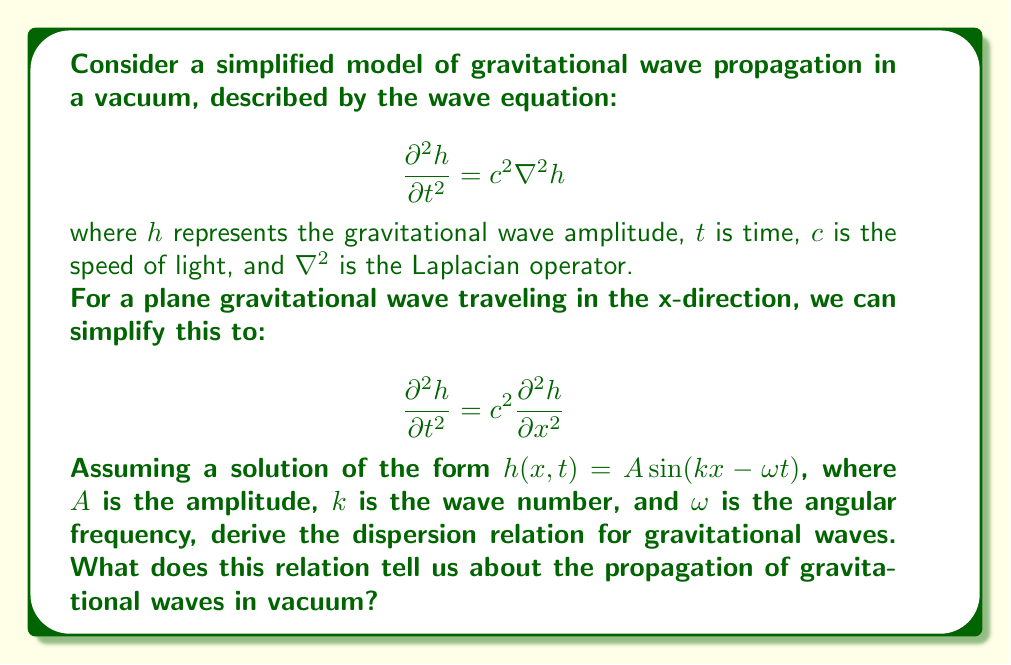Could you help me with this problem? Let's approach this step-by-step:

1) We start with the assumed solution: $h(x,t) = A \sin(kx - \omega t)$

2) To use this in our wave equation, we need to calculate the second derivatives with respect to $t$ and $x$:

   $\frac{\partial h}{\partial t} = -A\omega \cos(kx - \omega t)$
   $\frac{\partial^2 h}{\partial t^2} = -A\omega^2 \sin(kx - \omega t)$

   $\frac{\partial h}{\partial x} = Ak \cos(kx - \omega t)$
   $\frac{\partial^2 h}{\partial x^2} = -Ak^2 \sin(kx - \omega t)$

3) Substituting these into our wave equation:

   $-A\omega^2 \sin(kx - \omega t) = c^2(-Ak^2 \sin(kx - \omega t))$

4) The $A \sin(kx - \omega t)$ terms cancel out on both sides, leaving us with:

   $\omega^2 = c^2k^2$

5) This is the dispersion relation for gravitational waves. We can rearrange it as:

   $\omega = ck$

6) Recall that the phase velocity $v_p$ is given by $\omega/k$, so:

   $v_p = \frac{\omega}{k} = c$

This dispersion relation tells us that:

a) Gravitational waves in vacuum propagate at the speed of light, $c$.
b) The phase velocity is constant and independent of frequency or wavelength.
c) There is no dispersion, meaning all frequencies travel at the same speed.

This is consistent with Einstein's theory of general relativity, which predicts that gravitational waves should propagate at the speed of light in vacuum.
Answer: $\omega = ck$, indicating gravitational waves propagate at the speed of light without dispersion. 